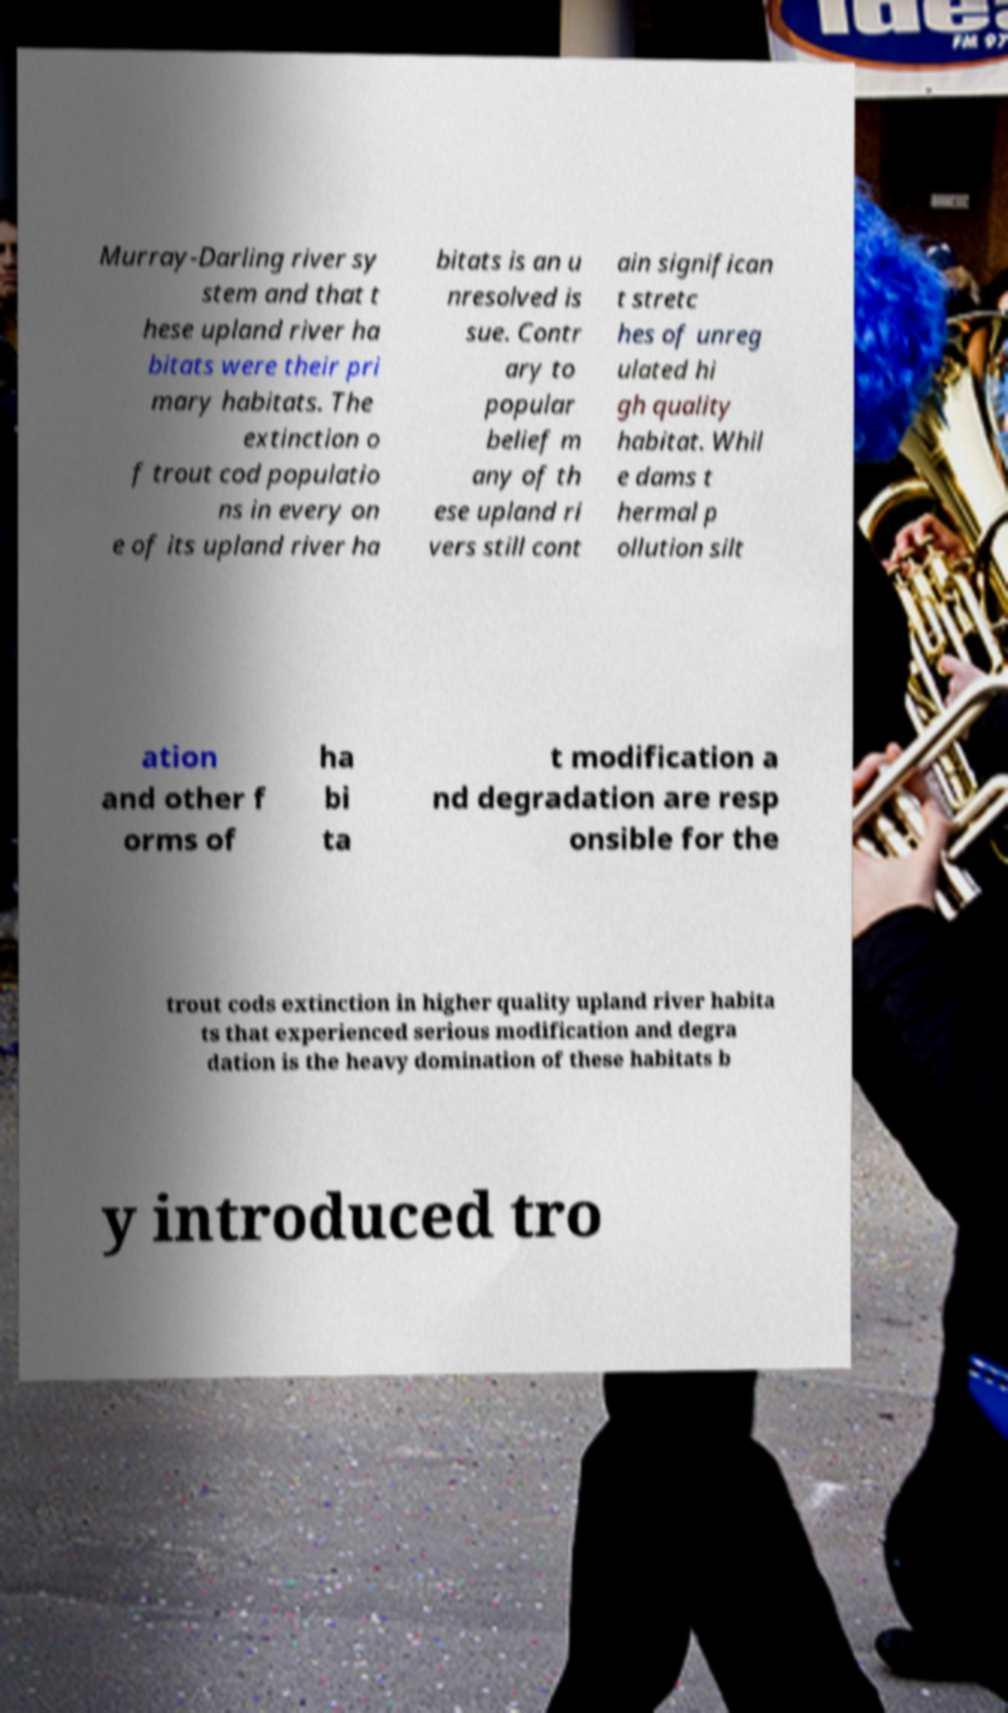Could you assist in decoding the text presented in this image and type it out clearly? Murray-Darling river sy stem and that t hese upland river ha bitats were their pri mary habitats. The extinction o f trout cod populatio ns in every on e of its upland river ha bitats is an u nresolved is sue. Contr ary to popular belief m any of th ese upland ri vers still cont ain significan t stretc hes of unreg ulated hi gh quality habitat. Whil e dams t hermal p ollution silt ation and other f orms of ha bi ta t modification a nd degradation are resp onsible for the trout cods extinction in higher quality upland river habita ts that experienced serious modification and degra dation is the heavy domination of these habitats b y introduced tro 